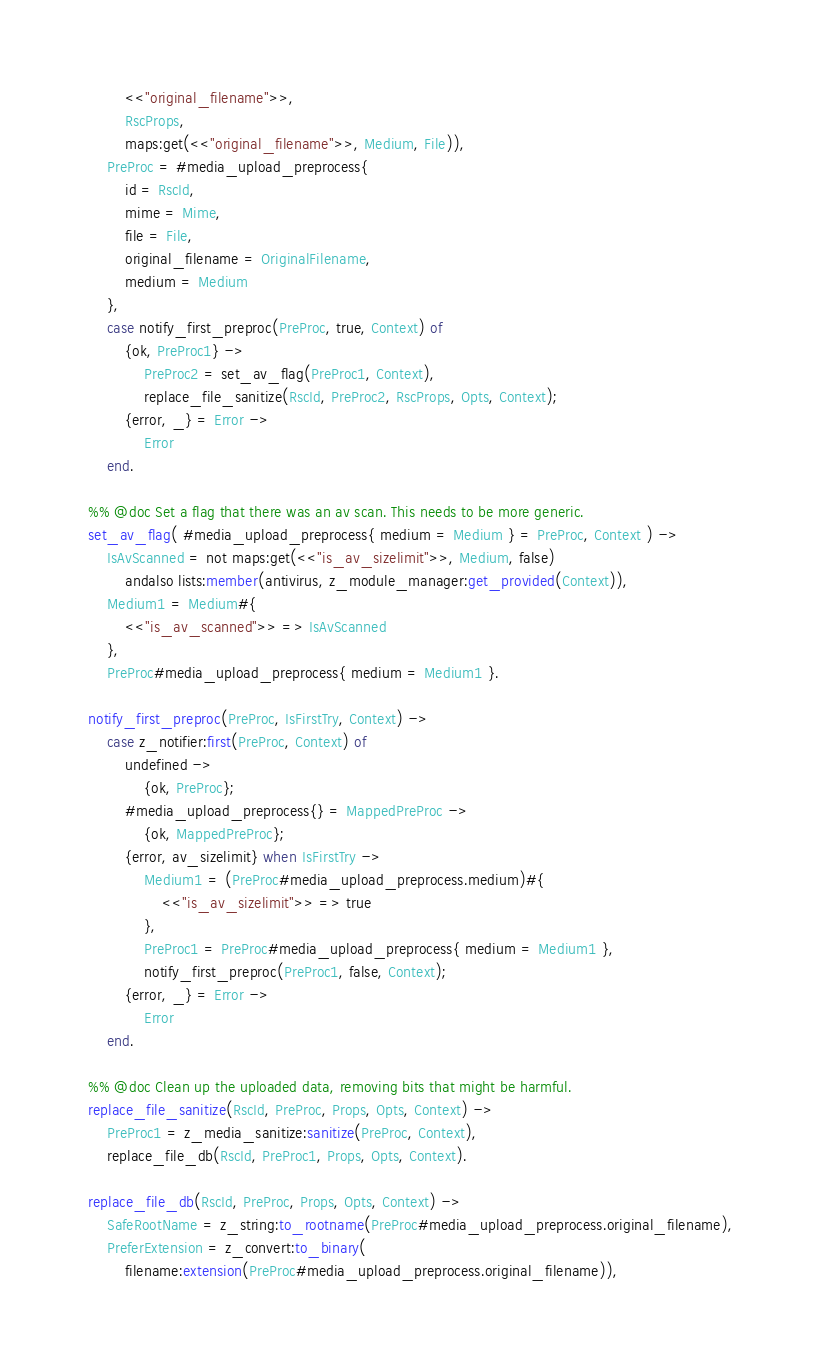Convert code to text. <code><loc_0><loc_0><loc_500><loc_500><_Erlang_>        <<"original_filename">>,
        RscProps,
        maps:get(<<"original_filename">>, Medium, File)),
    PreProc = #media_upload_preprocess{
        id = RscId,
        mime = Mime,
        file = File,
        original_filename = OriginalFilename,
        medium = Medium
    },
    case notify_first_preproc(PreProc, true, Context) of
        {ok, PreProc1} ->
            PreProc2 = set_av_flag(PreProc1, Context),
            replace_file_sanitize(RscId, PreProc2, RscProps, Opts, Context);
        {error, _} = Error ->
            Error
    end.

%% @doc Set a flag that there was an av scan. This needs to be more generic.
set_av_flag( #media_upload_preprocess{ medium = Medium } = PreProc, Context ) ->
    IsAvScanned = not maps:get(<<"is_av_sizelimit">>, Medium, false)
        andalso lists:member(antivirus, z_module_manager:get_provided(Context)),
    Medium1 = Medium#{
        <<"is_av_scanned">> => IsAvScanned
    },
    PreProc#media_upload_preprocess{ medium = Medium1 }.

notify_first_preproc(PreProc, IsFirstTry, Context) ->
    case z_notifier:first(PreProc, Context) of
        undefined ->
            {ok, PreProc};
        #media_upload_preprocess{} = MappedPreProc ->
            {ok, MappedPreProc};
        {error, av_sizelimit} when IsFirstTry ->
            Medium1 = (PreProc#media_upload_preprocess.medium)#{
                <<"is_av_sizelimit">> => true
            },
            PreProc1 = PreProc#media_upload_preprocess{ medium = Medium1 },
            notify_first_preproc(PreProc1, false, Context);
        {error, _} = Error ->
            Error
    end.

%% @doc Clean up the uploaded data, removing bits that might be harmful.
replace_file_sanitize(RscId, PreProc, Props, Opts, Context) ->
    PreProc1 = z_media_sanitize:sanitize(PreProc, Context),
    replace_file_db(RscId, PreProc1, Props, Opts, Context).

replace_file_db(RscId, PreProc, Props, Opts, Context) ->
    SafeRootName = z_string:to_rootname(PreProc#media_upload_preprocess.original_filename),
    PreferExtension = z_convert:to_binary(
        filename:extension(PreProc#media_upload_preprocess.original_filename)),</code> 